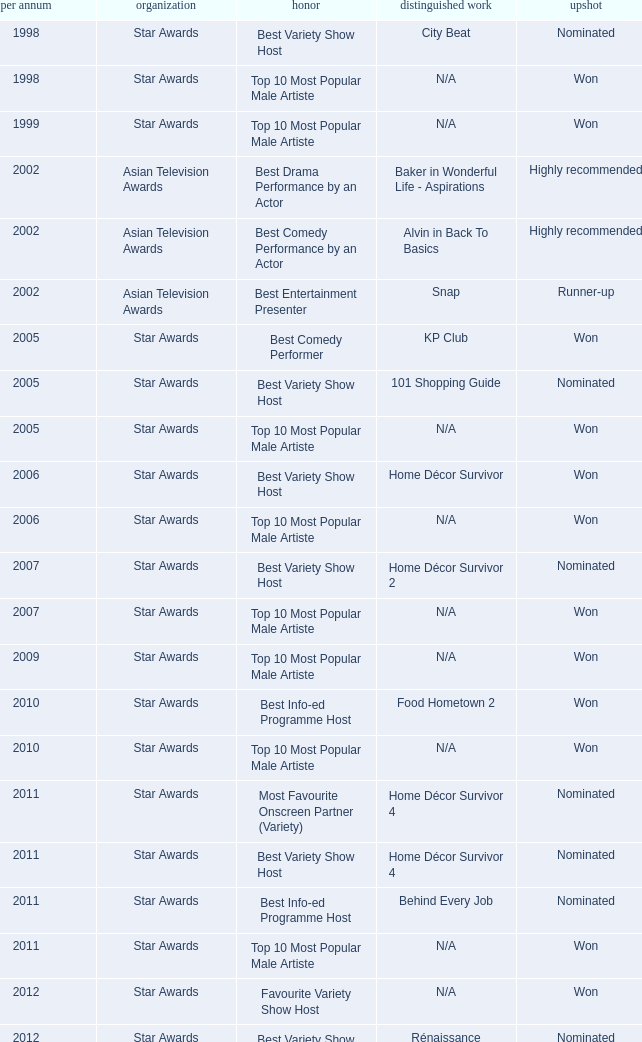What is the name of the Representative Work in a year later than 2005 with a Result of nominated, and an Award of best variety show host? Home Décor Survivor 2, Home Décor Survivor 4, Rénaissance, Jobs Around The World. 